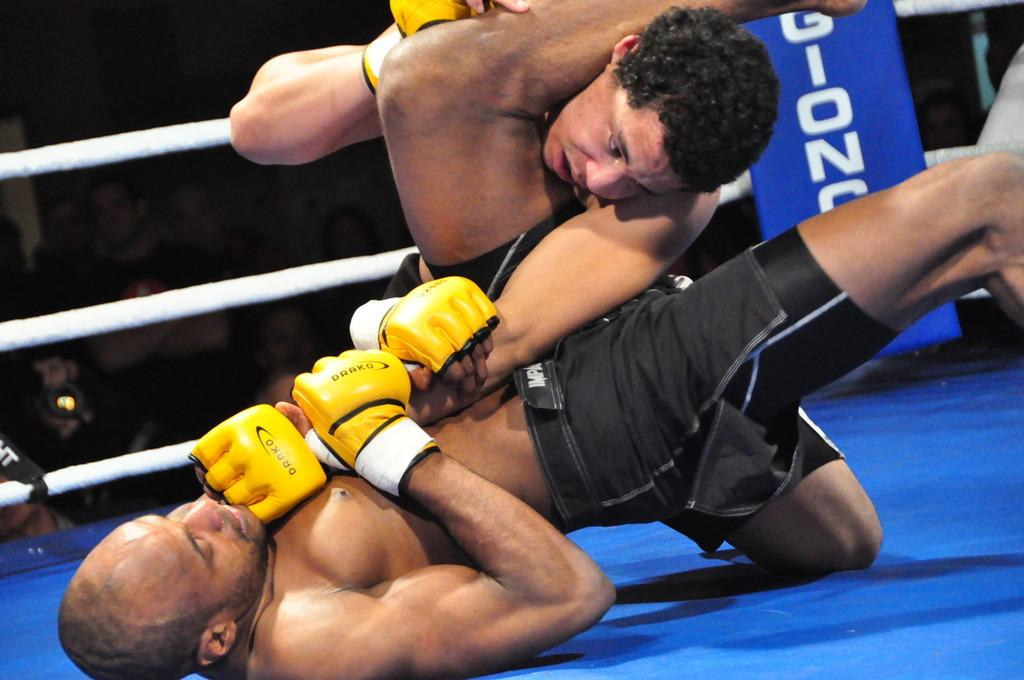<image>
Create a compact narrative representing the image presented. Two men are wrestling in a rink and wearing gloves with the word drako on them. 